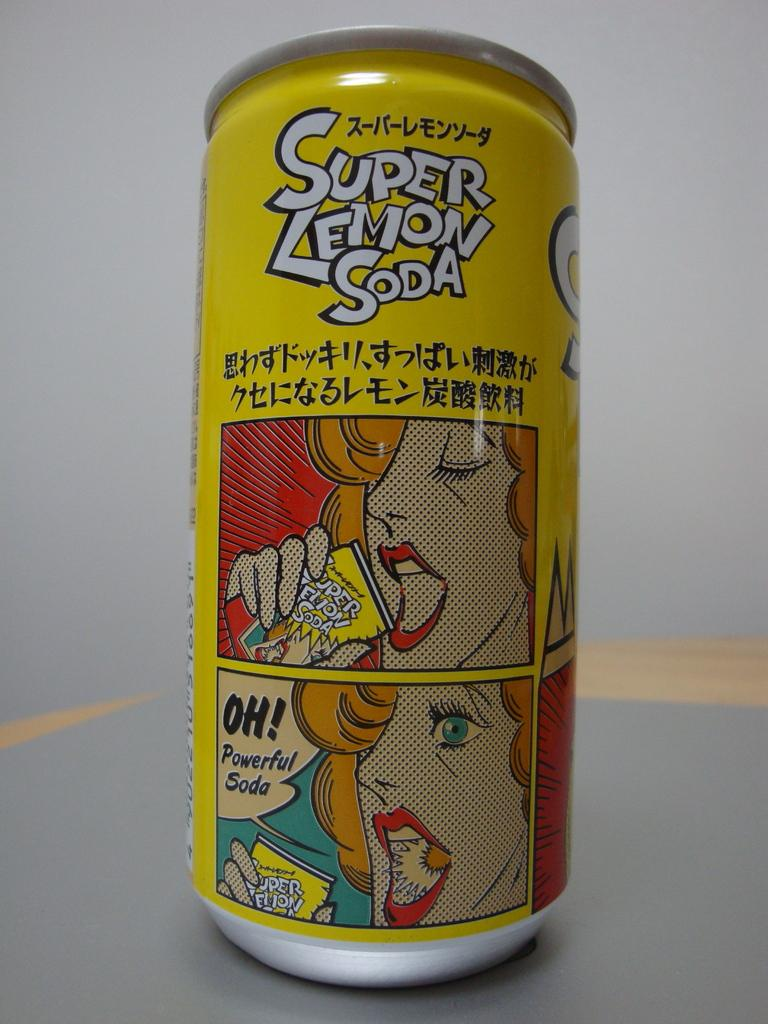<image>
Summarize the visual content of the image. A can of Super Lemon Soda sits on a gray countertop. 